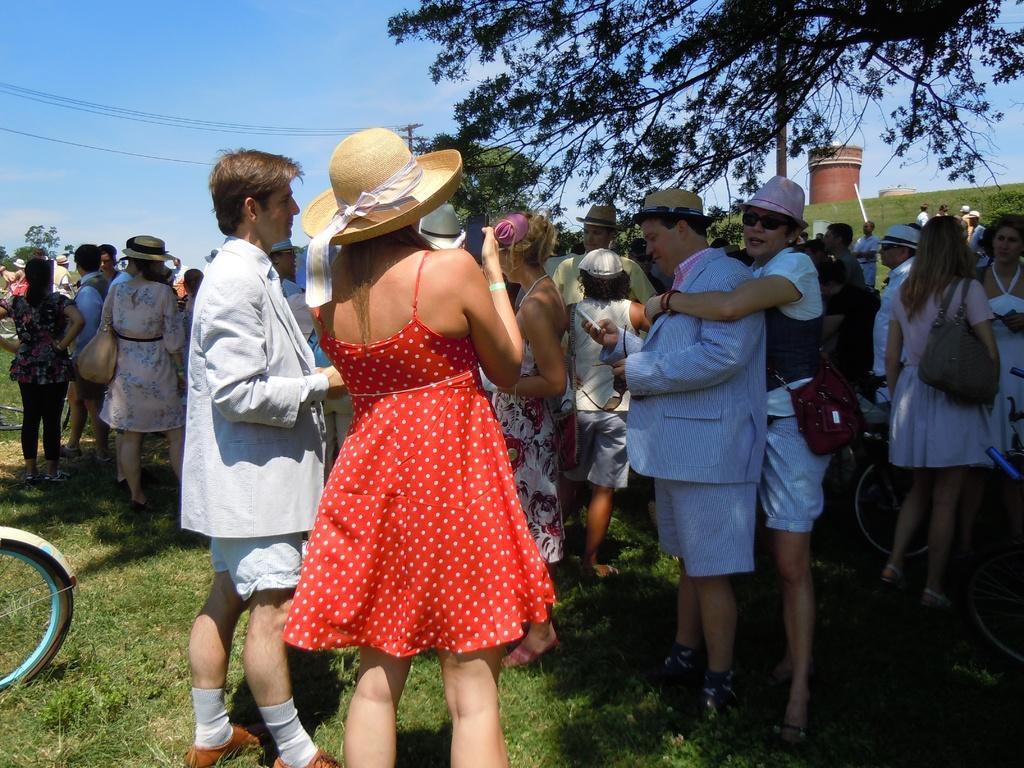Describe this image in one or two sentences. In this image there are many people. Few of them are wearing hats. Here there are trees. This is looking like a tower. 